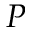Convert formula to latex. <formula><loc_0><loc_0><loc_500><loc_500>P</formula> 